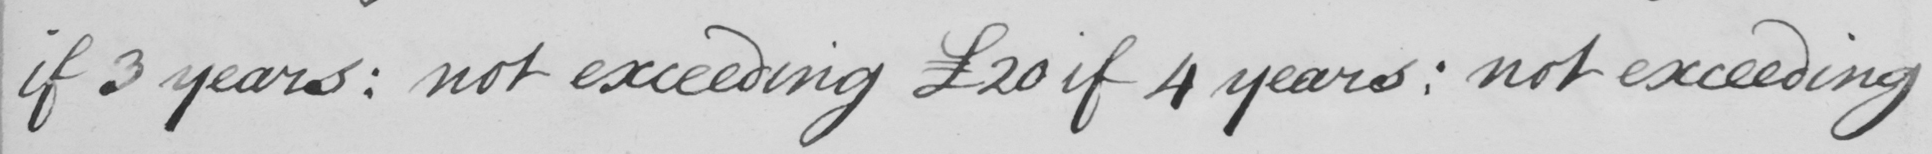What text is written in this handwritten line? if 3 years :  not exceeding £20 if 4 years :  not exceeding 